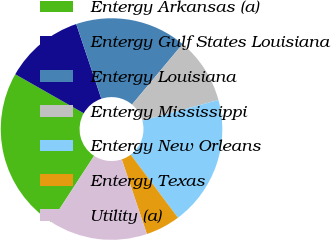Convert chart to OTSL. <chart><loc_0><loc_0><loc_500><loc_500><pie_chart><fcel>Entergy Arkansas (a)<fcel>Entergy Gulf States Louisiana<fcel>Entergy Louisiana<fcel>Entergy Mississippi<fcel>Entergy New Orleans<fcel>Entergy Texas<fcel>Utility (a)<nl><fcel>24.05%<fcel>11.6%<fcel>16.24%<fcel>9.7%<fcel>18.99%<fcel>5.06%<fcel>14.35%<nl></chart> 